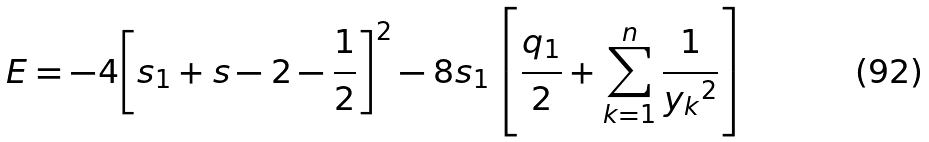<formula> <loc_0><loc_0><loc_500><loc_500>E = - 4 { \left [ s _ { 1 } + s - { 2 } - \frac { 1 } { 2 } \right ] } ^ { 2 } - 8 s _ { 1 } \left [ \frac { q _ { 1 } } { 2 } + \sum _ { k = 1 } ^ { n } \frac { 1 } { { y _ { k } } ^ { 2 } } \right ]</formula> 